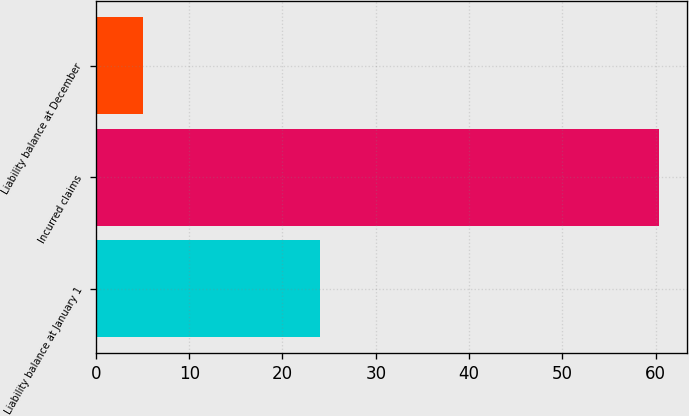<chart> <loc_0><loc_0><loc_500><loc_500><bar_chart><fcel>Liability balance at January 1<fcel>Incurred claims<fcel>Liability balance at December<nl><fcel>24<fcel>60.3<fcel>5<nl></chart> 